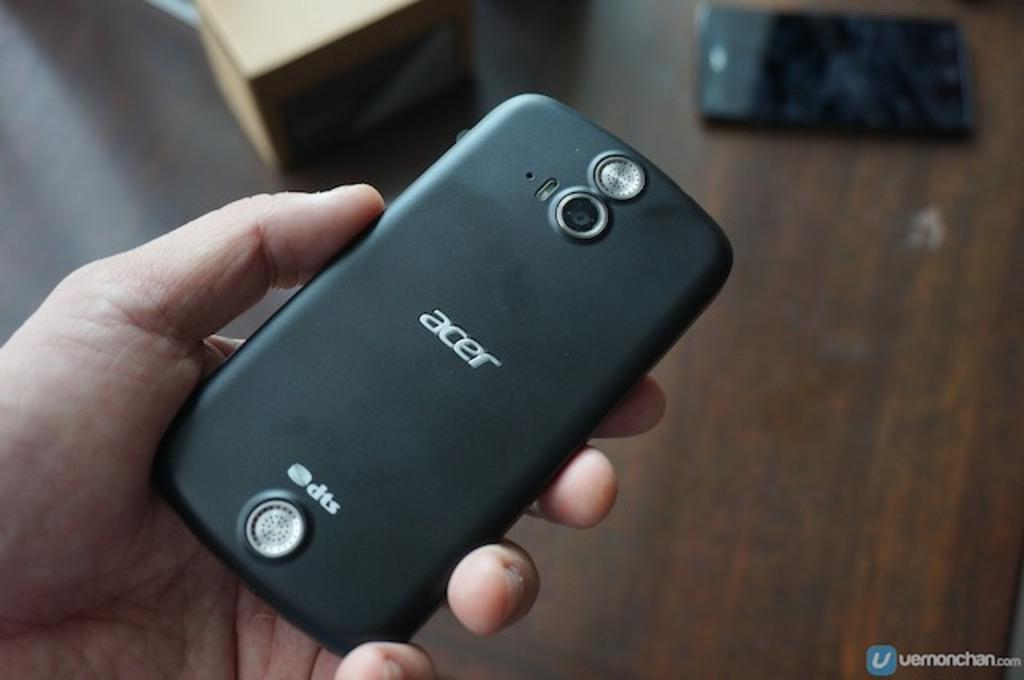<image>
Summarize the visual content of the image. hand holding an acer phone that features dts and a wood table that has another phone on it 